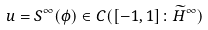Convert formula to latex. <formula><loc_0><loc_0><loc_500><loc_500>u = S ^ { \infty } ( \phi ) \in C ( [ - 1 , 1 ] \colon \widetilde { H } ^ { \infty } )</formula> 